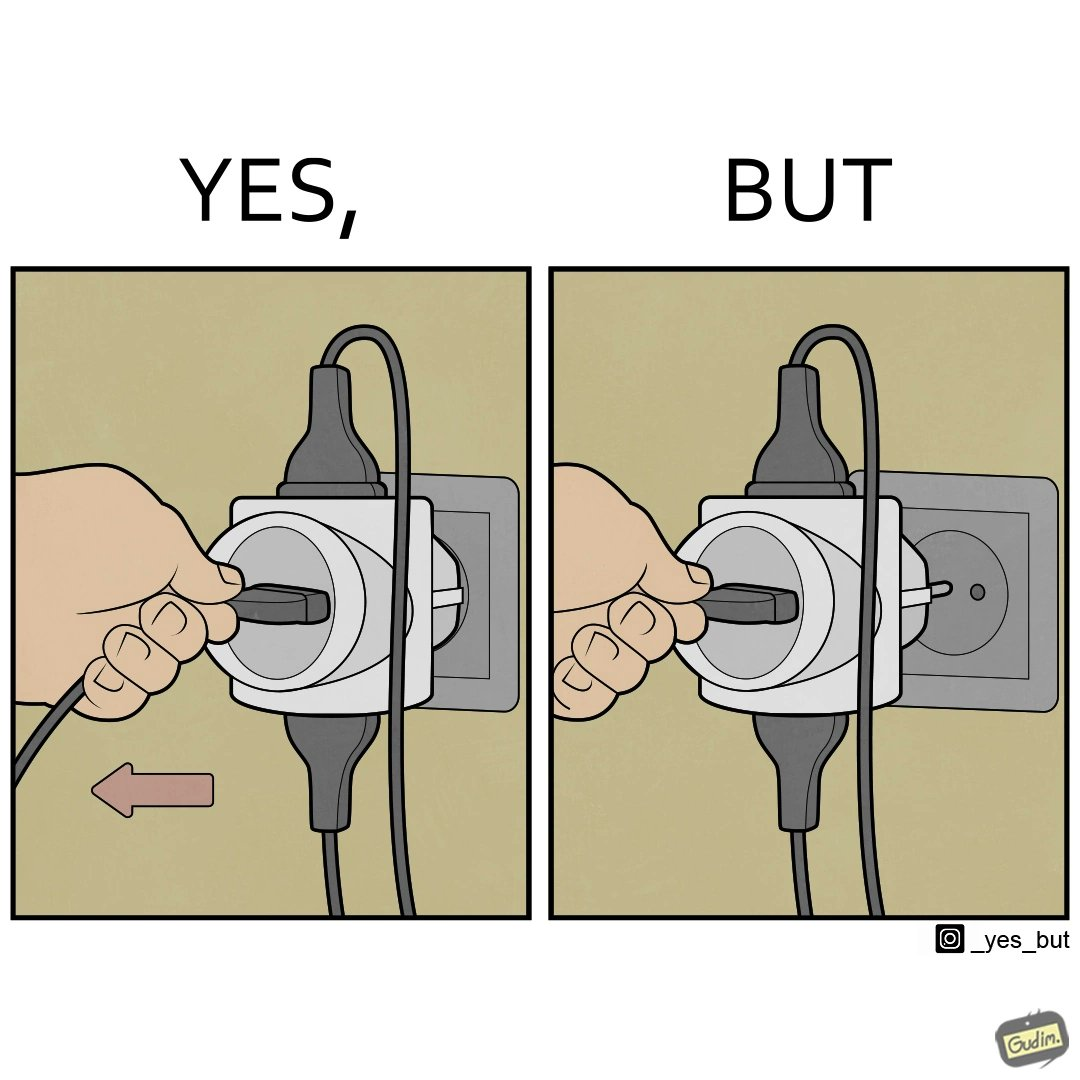What is shown in the left half versus the right half of this image? In the left part of the image: a pin being pulled off from a multi pin plug socket In the right part of the image: the multi pin plug is getting pulled off from the plug 